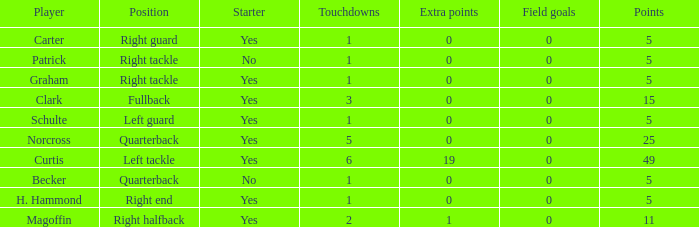Name the most touchdowns for norcross 5.0. 